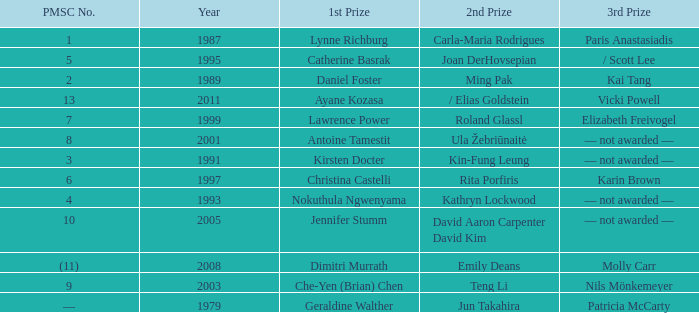In what year did Kin-fung Leung get 2nd prize? 1991.0. 